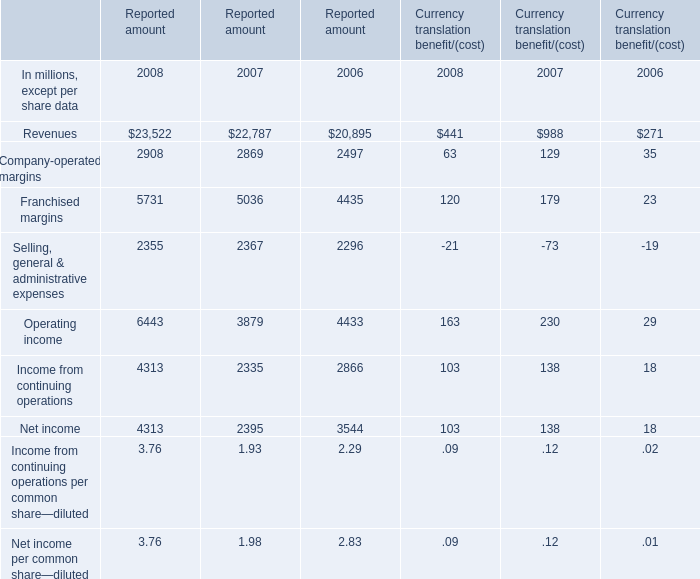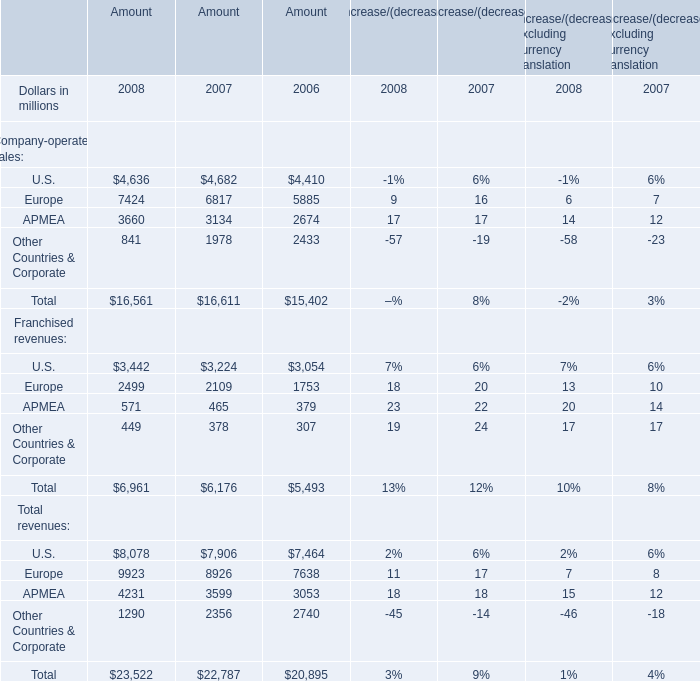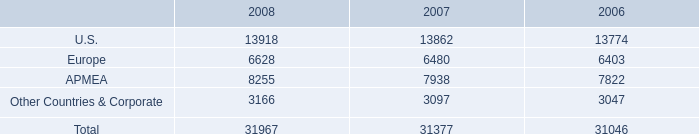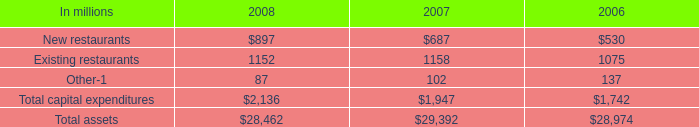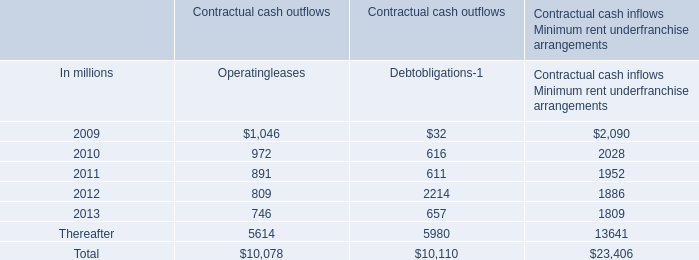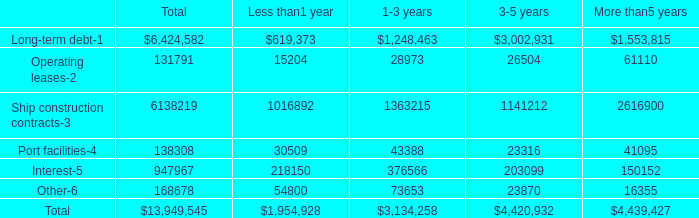what percentage of payments was long-term debt? 
Computations: (6424582 / 13949545)
Answer: 0.46056. 